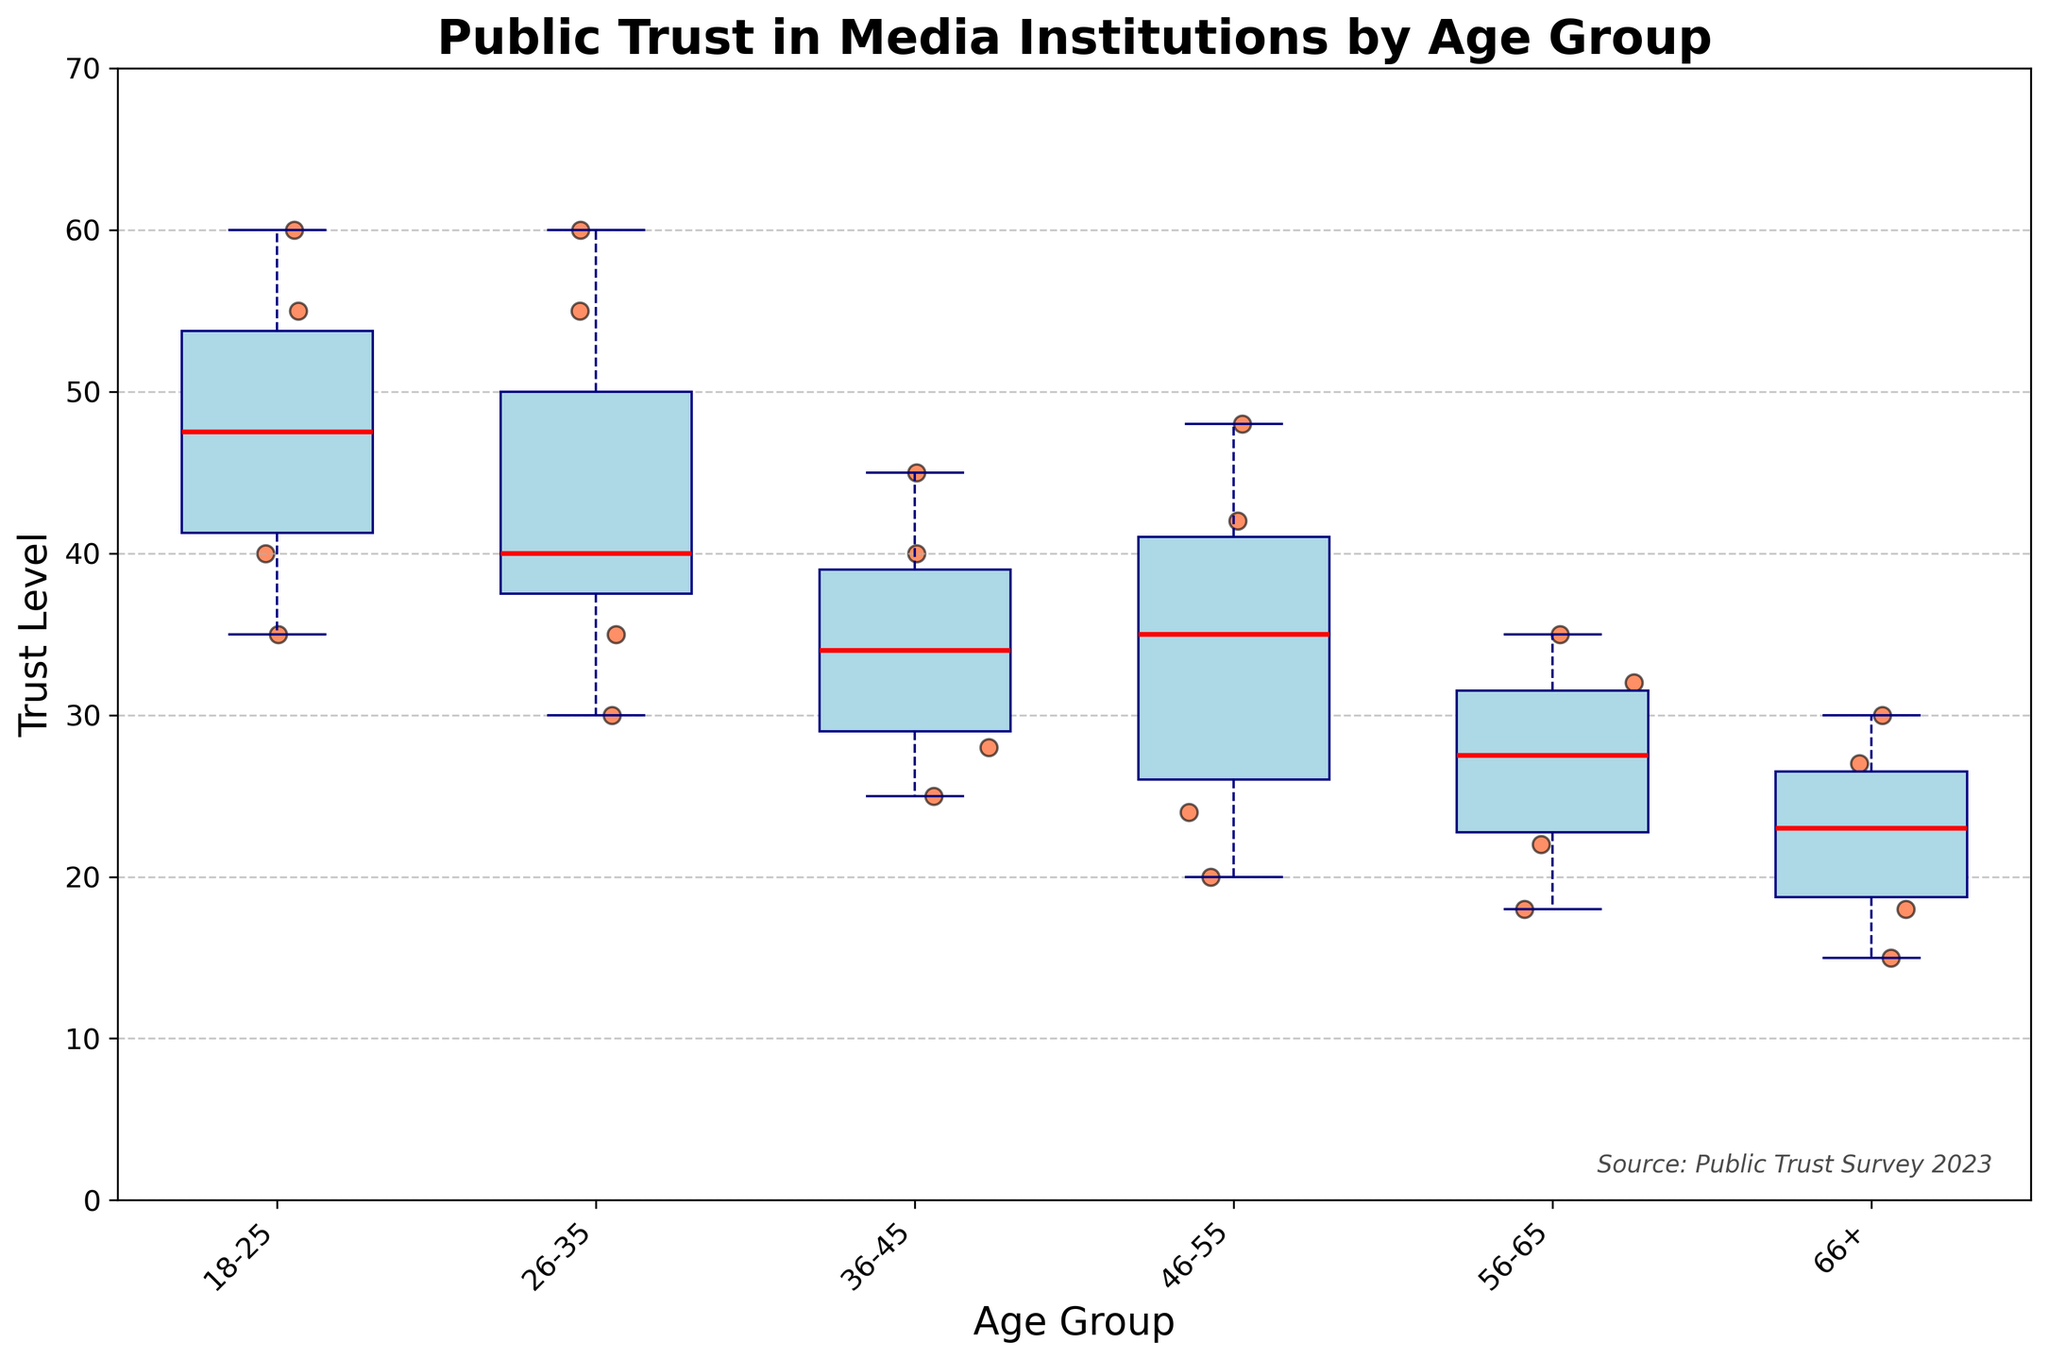What is the title of the plot? The title of the plot is displayed at the top in bold text. It reads "Public Trust in Media Institutions by Age Group."
Answer: Public Trust in Media Institutions by Age Group What is the range of Trust Levels displayed on the y-axis? The Trust Levels range is indicated on the y-axis, starting from 0 up to 70.
Answer: 0 to 70 Which age group has the highest median Trust Level? The median Trust Level is shown by the red lines within the boxes. The highest median line is positioned around the age group "18-25."
Answer: 18-25 How do the Trust Levels for the 66+ age group compare to those for the 18-25 age group? The Trust Levels for the 66+ age group are generally lower compared to the 18-25 age group, as evidenced by their respective median lines and overall position of data points.
Answer: Lower Does the box representing the 46-55 age group overlap with the box for the 36-45 age group? The boxes for the age groups 46-55 and 36-45 overlap slightly at the top of the former and the bottom of the latter, showing a continuity in Trust Levels.
Answer: Yes What's the interquartile range (IQR) for the 26-35 age group? The IQR is the difference between the third quartile (Q3) and the first quartile (Q1) within a box plot. For the 26-35 age group, Q3 is about 50, and Q1 is around 35. Thus, IQR = 50 - 35.
Answer: 15 Which data point has the highest Trust Level, and what age group does it belong to? The scatter point at the highest Trust Level is at 60, which belongs to the "18-25" age group.
Answer: 60, 18-25 Is there any age group that has outliers, and if so, which one? Outliers can be identified as individual data points outside the whiskers of the box plots. The 56-65 age group has an outlier above the whisker, which is the point at 35.
Answer: 56-65 What is the median Trust Level for the age group 36-45? The median Trust Level is shown by the red line inside the box. For the 36-45 age group, it is around 35.
Answer: 35 How do the Trust Levels vary within the 26-35 age group? The scatter points for the 26-35 age group show Trust Levels ranging from 30 to 60, as reflected in the positions of the individual points.
Answer: 30 to 60 